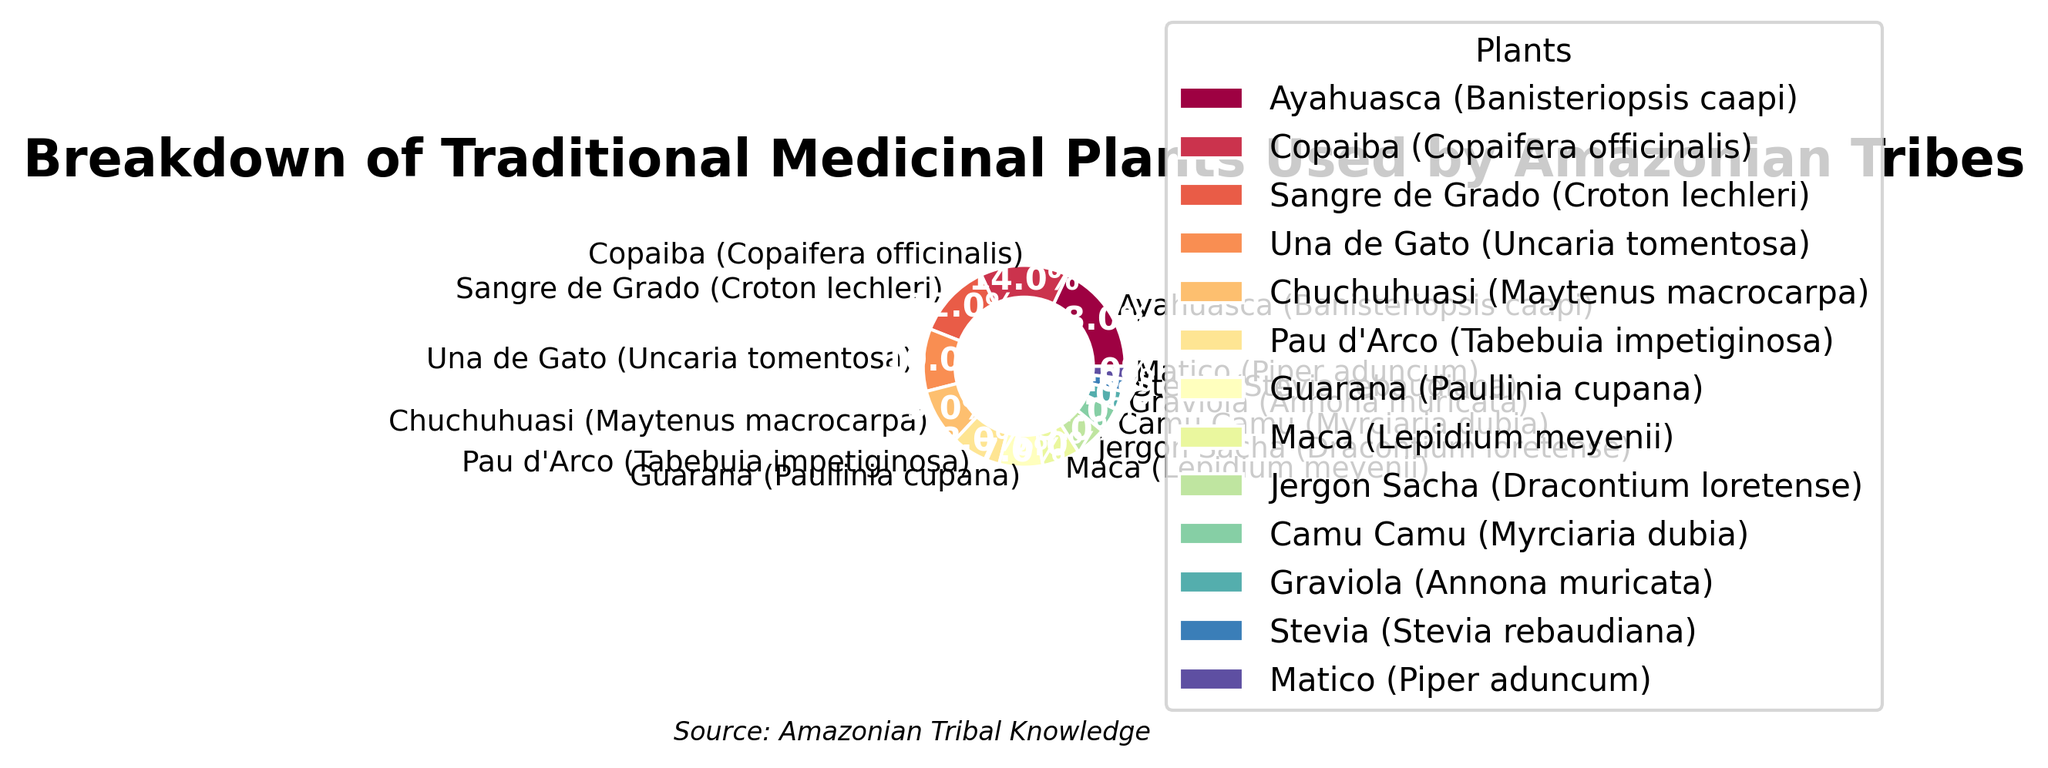Which plant has the highest percentage usage among Amazonian tribes? Ayahuasca (Banisteriopsis caapi) has the highest percentage at 18%, as indicated by the largest wedge in the pie chart.
Answer: Ayahuasca (Banisteriopsis caapi) How much more is Ayahuasca used compared to Graviola? Ayahuasca is used by 18% while Graviola is used by 3%. The difference in usage is 18% - 3% = 15%.
Answer: 15% What is the combined usage percentage of Una de Gato and Chuchuhuasi? Una de Gato is used by 10% and Chuchuhuasi by 9%. Combined, their usage is 10% + 9% = 19%.
Answer: 19% Is Copaiba used more than Maca? Yes, Copaiba is used by 14%, while Maca is used by 6%. 14% is greater than 6%.
Answer: Yes Which two plants have the smallest percentage usage and what is their combined total? The two plants with the smallest percentage usage are Stevia and Matico, each at 2%. Combined, their total is 2% + 2% = 4%.
Answer: 4% How does the percentage use of Pau d'Arco compare to that of Guarana? Pau d'Arco is used by 8%, while Guarana is used by 7%. Pau d'Arco is used 1% more than Guarana.
Answer: Pau d'Arco is used 1% more What fraction of the total percentage is accounted for by the top three plants? The top three plants are Ayahuasca (18%), Copaiba (14%), and Sangre de Grado (12%). Combined, their percentage is 18% + 14% + 12% = 44%.
Answer: 44% What is the average percentage usage of all plants listed? The list includes 13 plants. Summing their percentages: 18 + 14 + 12 + 10 + 9 + 8 + 7 + 6 + 5 + 4 + 3 + 2 + 2 = 100. Dividing by 13 yields an average usage of 100/13 ≈ 7.7%.
Answer: ≈ 7.7% Are there more plants used less than 10% or more than 10%? Plants used less than 10%: Chuchuhuasi, Pau d'Arco, Guarana, Maca, Jergon Sacha, Camu Camu, Graviola, Stevia, Matico (9 in total). Plants used more than 10%: Ayahuasca, Copaiba, Sangre de Grado, Una de Gato (4 in total).
Answer: More plants are used less than 10% 